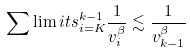Convert formula to latex. <formula><loc_0><loc_0><loc_500><loc_500>\sum \lim i t s _ { i = K } ^ { k - 1 } \frac { 1 } { v _ { i } ^ { \beta } } \lesssim \frac { 1 } { v _ { k - 1 } ^ { \beta } }</formula> 